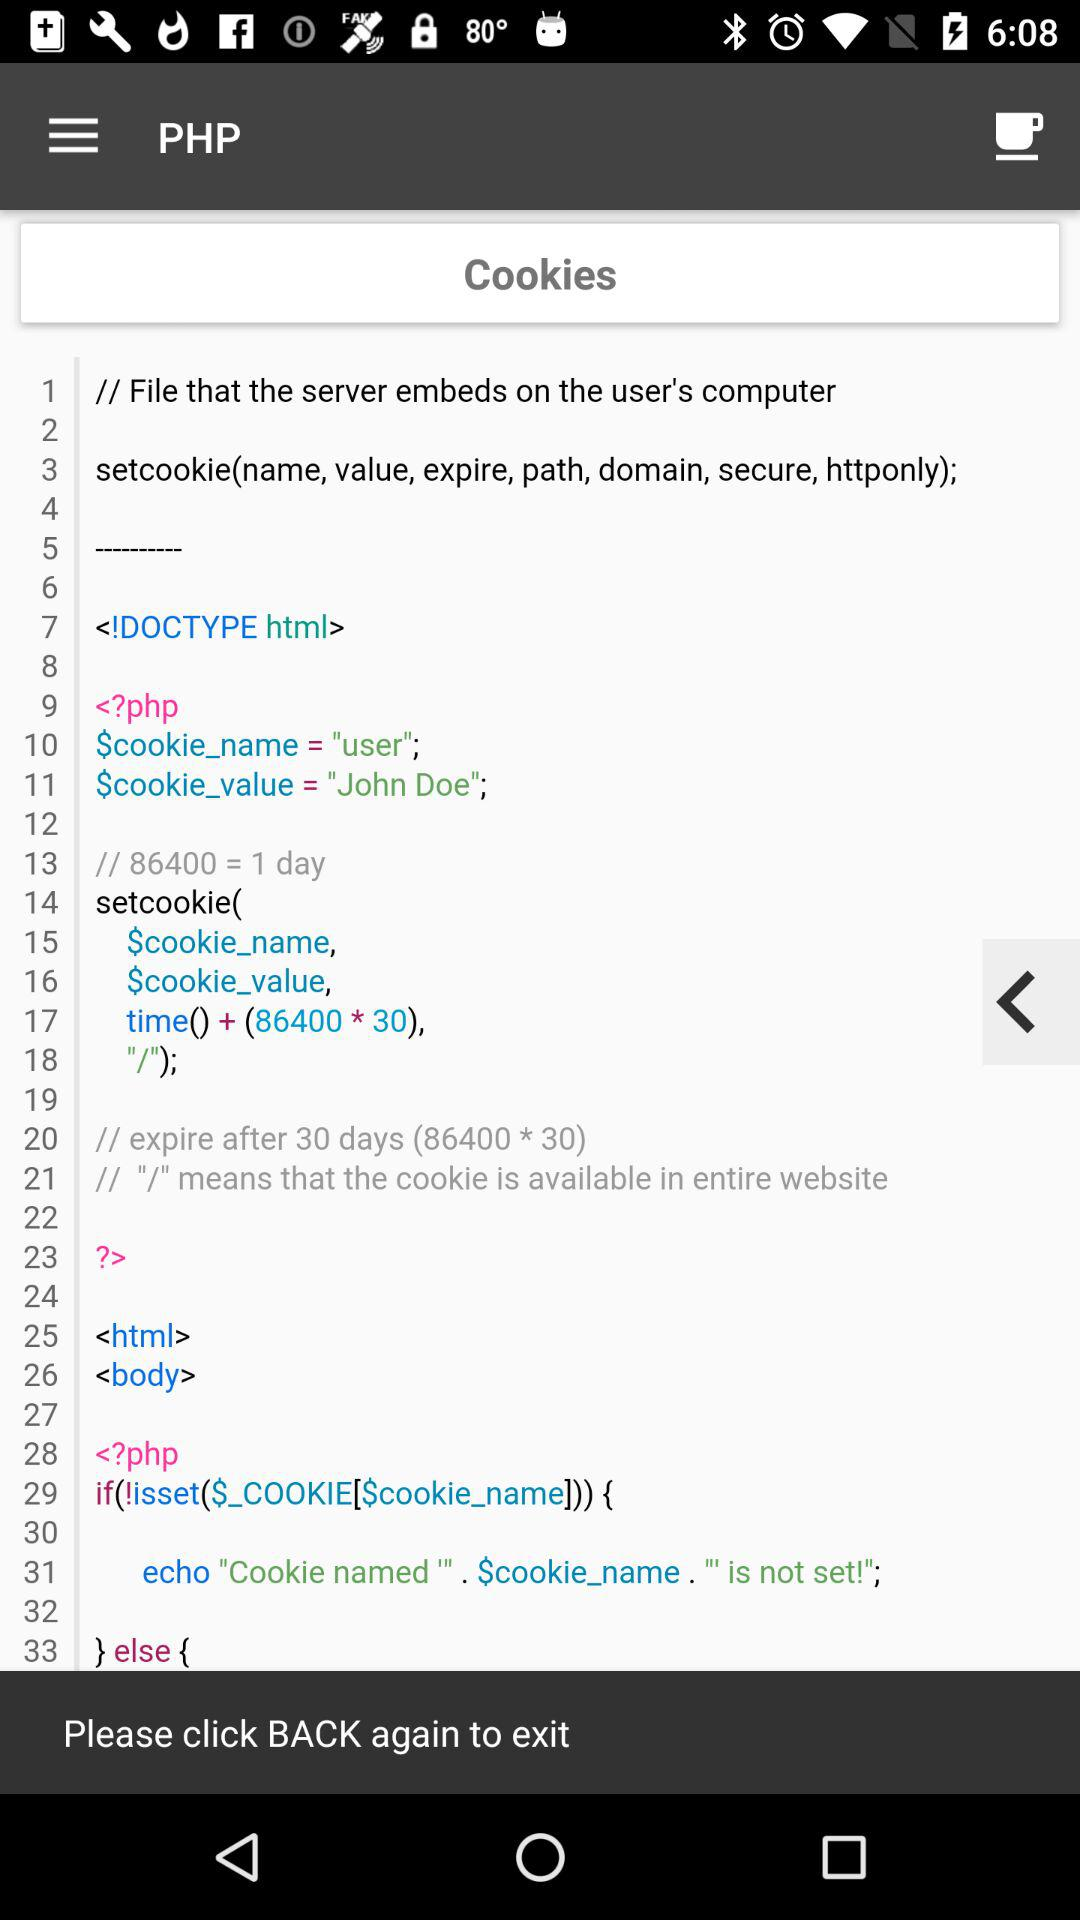What is the name of the cookie? The name of the cookie is "user". 